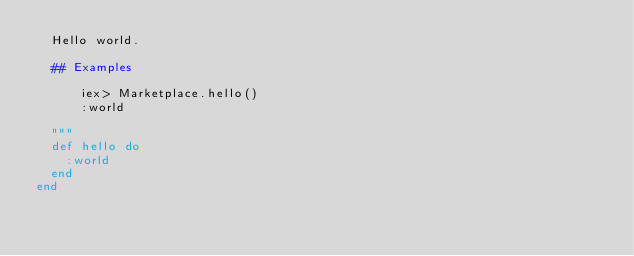<code> <loc_0><loc_0><loc_500><loc_500><_Elixir_>  Hello world.

  ## Examples

      iex> Marketplace.hello()
      :world

  """
  def hello do
    :world
  end
end
</code> 